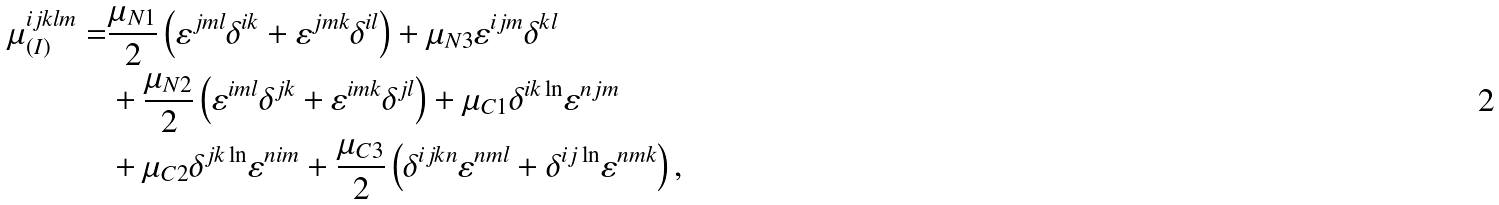Convert formula to latex. <formula><loc_0><loc_0><loc_500><loc_500>\mu _ { ( I ) } ^ { i j k l m } = & \frac { \mu _ { N 1 } } { 2 } \left ( \varepsilon ^ { j m l } \delta ^ { i k } + \varepsilon ^ { j m k } \delta ^ { i l } \right ) + \mu _ { N 3 } \varepsilon ^ { i j m } \delta ^ { k l } \\ & + \frac { \mu _ { N 2 } } { 2 } \left ( \varepsilon ^ { i m l } \delta ^ { j k } + \varepsilon ^ { i m k } \delta ^ { j l } \right ) + \mu _ { C 1 } \delta ^ { i k \ln } \varepsilon ^ { n j m } \\ & + \mu _ { C 2 } \delta ^ { j k \ln } \varepsilon ^ { n i m } + \frac { \mu _ { C 3 } } { 2 } \left ( \delta ^ { i j k n } \varepsilon ^ { n m l } + \delta ^ { i j \ln } \varepsilon ^ { n m k } \right ) ,</formula> 